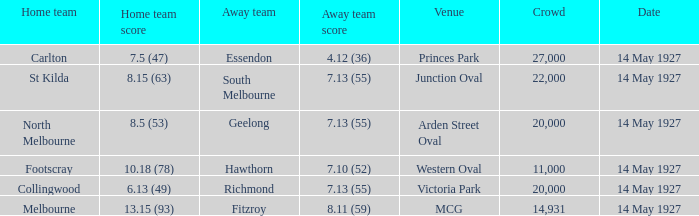Which away team had a score of 4.12 (36)? Essendon. 